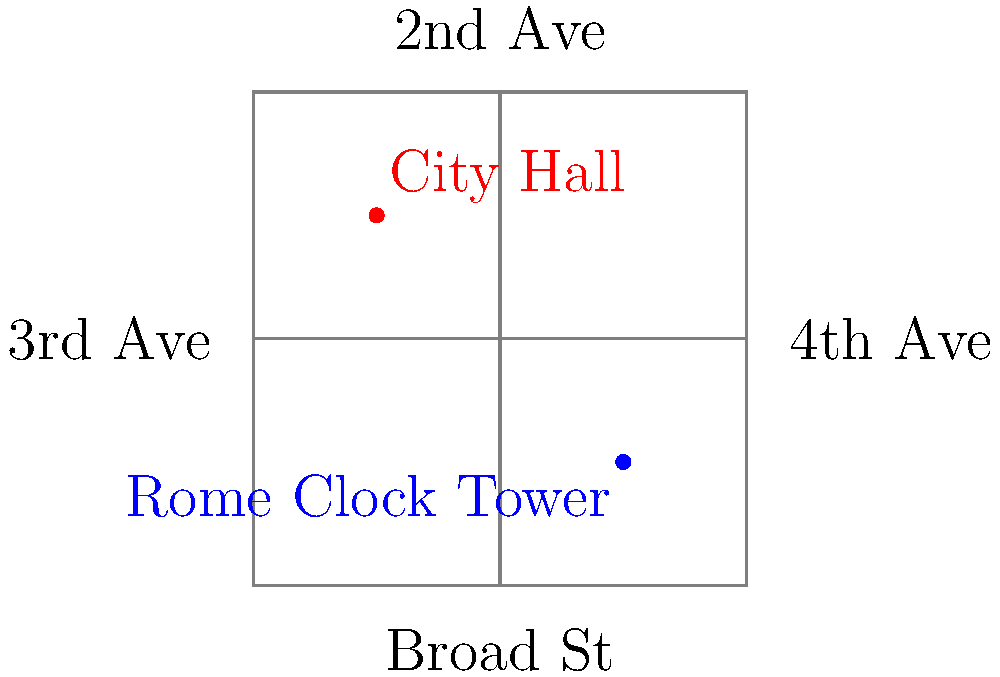Based on the simplified street map of downtown Rome, Georgia, in which direction would you need to walk from City Hall to reach the Rome Clock Tower? To determine the direction from City Hall to the Rome Clock Tower, let's follow these steps:

1. Locate City Hall on the map (red dot).
2. Locate the Rome Clock Tower on the map (blue dot).
3. Observe the relative positions of these two landmarks:
   - City Hall is in the upper-left quadrant of the map.
   - The Rome Clock Tower is in the lower-right quadrant of the map.
4. To get from City Hall to the Rome Clock Tower, you need to:
   - Move down (south) along 3rd Avenue.
   - Then move right (east) along Broad Street.
5. The combination of moving south and east results in a southeastern direction.

Therefore, to walk from City Hall to the Rome Clock Tower, you would need to go in a southeastern direction.
Answer: Southeast 